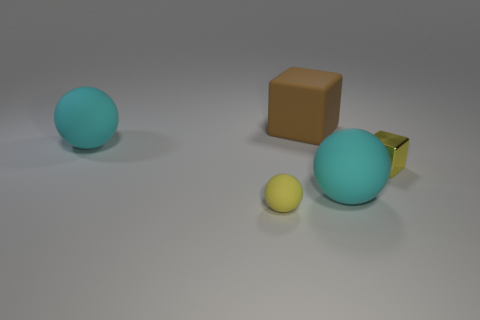Can we tell the texture of the different objects? The big and small balls give the impression of being made of rubber due to their matte finish, while the small yellow cube and the brown object both appear to have smoother, possibly polished surfaces, reflecting light more sharply. 